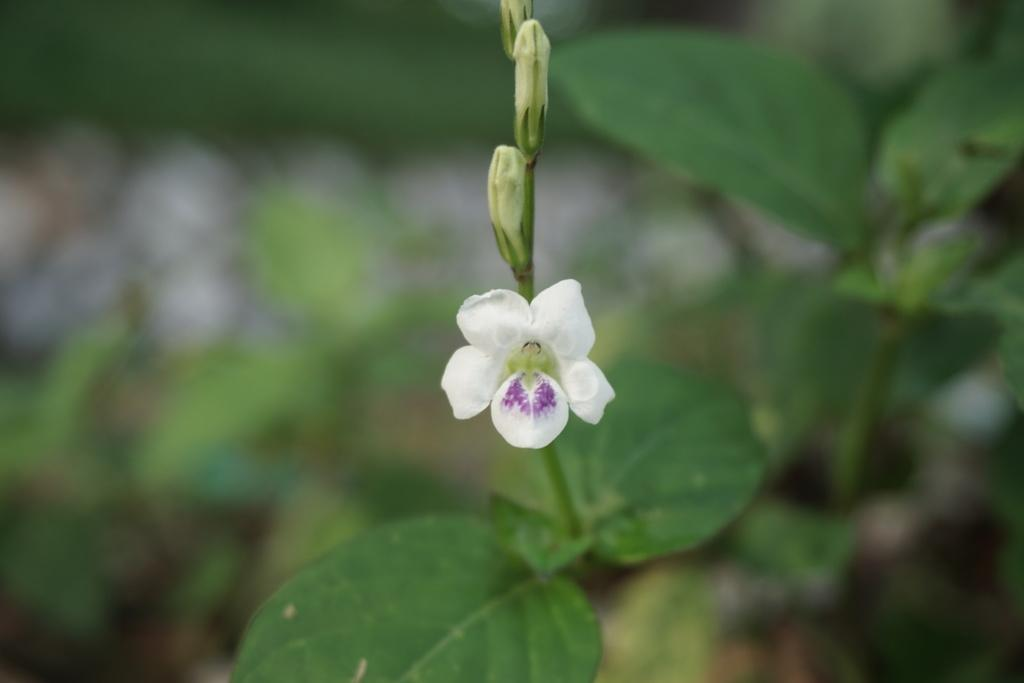What is the main subject in the foreground of the image? There is a white flower in the foreground of the image. What is the relationship between the flower and the plant? The flower is part of a plant. What is the growth stage of the other flowers on the plant? There are buds on the plant. What can be seen in the background of the image? In the background, there are blurred plants. What type of pizzas can be seen in the image? A: There are no pizzas present in the image; it features a white flower and a plant. Can you hear any thunder in the image? There is no sound or indication of thunder in the image, as it is a still photograph. 